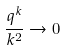<formula> <loc_0><loc_0><loc_500><loc_500>\frac { q ^ { k } } { k ^ { 2 } } \rightarrow 0</formula> 